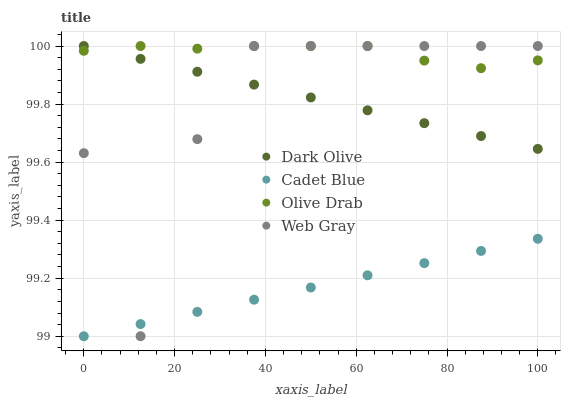Does Cadet Blue have the minimum area under the curve?
Answer yes or no. Yes. Does Olive Drab have the maximum area under the curve?
Answer yes or no. Yes. Does Dark Olive have the minimum area under the curve?
Answer yes or no. No. Does Dark Olive have the maximum area under the curve?
Answer yes or no. No. Is Cadet Blue the smoothest?
Answer yes or no. Yes. Is Web Gray the roughest?
Answer yes or no. Yes. Is Web Gray the smoothest?
Answer yes or no. No. Is Dark Olive the roughest?
Answer yes or no. No. Does Cadet Blue have the lowest value?
Answer yes or no. Yes. Does Dark Olive have the lowest value?
Answer yes or no. No. Does Olive Drab have the highest value?
Answer yes or no. Yes. Is Cadet Blue less than Dark Olive?
Answer yes or no. Yes. Is Dark Olive greater than Cadet Blue?
Answer yes or no. Yes. Does Olive Drab intersect Web Gray?
Answer yes or no. Yes. Is Olive Drab less than Web Gray?
Answer yes or no. No. Is Olive Drab greater than Web Gray?
Answer yes or no. No. Does Cadet Blue intersect Dark Olive?
Answer yes or no. No. 